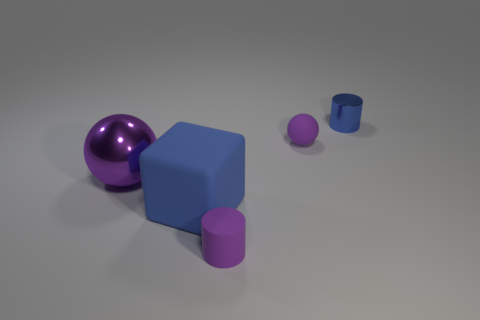What size is the other object that is the same shape as the big purple thing?
Ensure brevity in your answer.  Small. The object that is the same material as the large purple sphere is what size?
Your answer should be compact. Small. How many tiny rubber cylinders have the same color as the tiny matte ball?
Keep it short and to the point. 1. There is a cylinder that is the same color as the big rubber cube; what is its size?
Offer a terse response. Small. Is the color of the tiny cylinder that is in front of the cube the same as the object that is on the left side of the large blue matte thing?
Your answer should be very brief. Yes. What is the color of the matte cylinder that is the same size as the blue metal cylinder?
Your response must be concise. Purple. What number of other objects are there of the same shape as the small metal thing?
Keep it short and to the point. 1. What size is the blue object in front of the metallic cylinder?
Your answer should be compact. Large. What number of balls are to the right of the small purple matte thing that is behind the big rubber cube?
Provide a short and direct response. 0. How many other objects are there of the same size as the blue metal thing?
Offer a terse response. 2. 